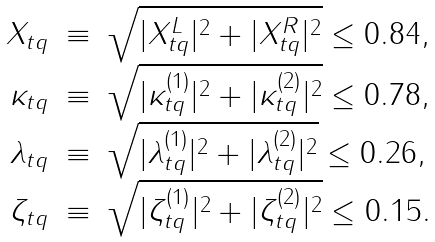<formula> <loc_0><loc_0><loc_500><loc_500>\begin{array} { r c l } X _ { t q } & \equiv & \sqrt { | X ^ { L } _ { t q } | ^ { 2 } + | X ^ { R } _ { t q } | ^ { 2 } } \leq 0 . 8 4 , \\ \kappa _ { t q } & \equiv & \sqrt { | \kappa ^ { ( 1 ) } _ { t q } | ^ { 2 } + | \kappa ^ { ( 2 ) } _ { t q } | ^ { 2 } } \leq 0 . 7 8 , \\ \lambda _ { t q } & \equiv & \sqrt { | \lambda ^ { ( 1 ) } _ { t q } | ^ { 2 } + | \lambda ^ { ( 2 ) } _ { t q } | ^ { 2 } } \leq 0 . 2 6 , \\ \zeta _ { t q } & \equiv & \sqrt { | \zeta ^ { ( 1 ) } _ { t q } | ^ { 2 } + | \zeta ^ { ( 2 ) } _ { t q } | ^ { 2 } } \leq 0 . 1 5 . \end{array}</formula> 